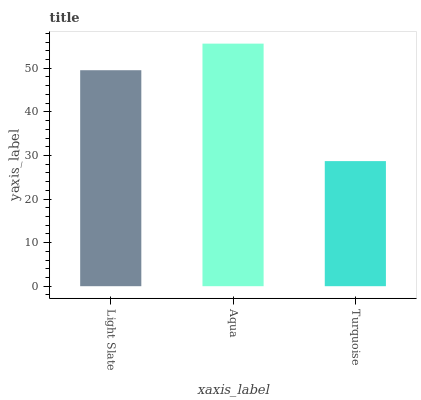Is Turquoise the minimum?
Answer yes or no. Yes. Is Aqua the maximum?
Answer yes or no. Yes. Is Aqua the minimum?
Answer yes or no. No. Is Turquoise the maximum?
Answer yes or no. No. Is Aqua greater than Turquoise?
Answer yes or no. Yes. Is Turquoise less than Aqua?
Answer yes or no. Yes. Is Turquoise greater than Aqua?
Answer yes or no. No. Is Aqua less than Turquoise?
Answer yes or no. No. Is Light Slate the high median?
Answer yes or no. Yes. Is Light Slate the low median?
Answer yes or no. Yes. Is Aqua the high median?
Answer yes or no. No. Is Turquoise the low median?
Answer yes or no. No. 